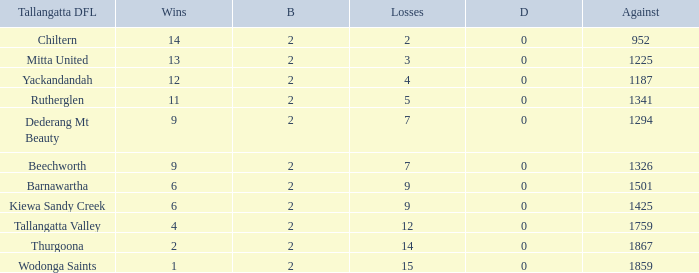What is the most byes with 11 wins and fewer than 1867 againsts? 2.0. 